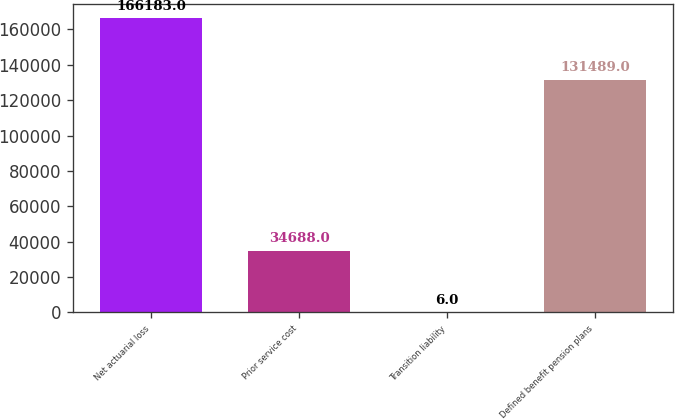Convert chart to OTSL. <chart><loc_0><loc_0><loc_500><loc_500><bar_chart><fcel>Net actuarial loss<fcel>Prior service cost<fcel>Transition liability<fcel>Defined benefit pension plans<nl><fcel>166183<fcel>34688<fcel>6<fcel>131489<nl></chart> 